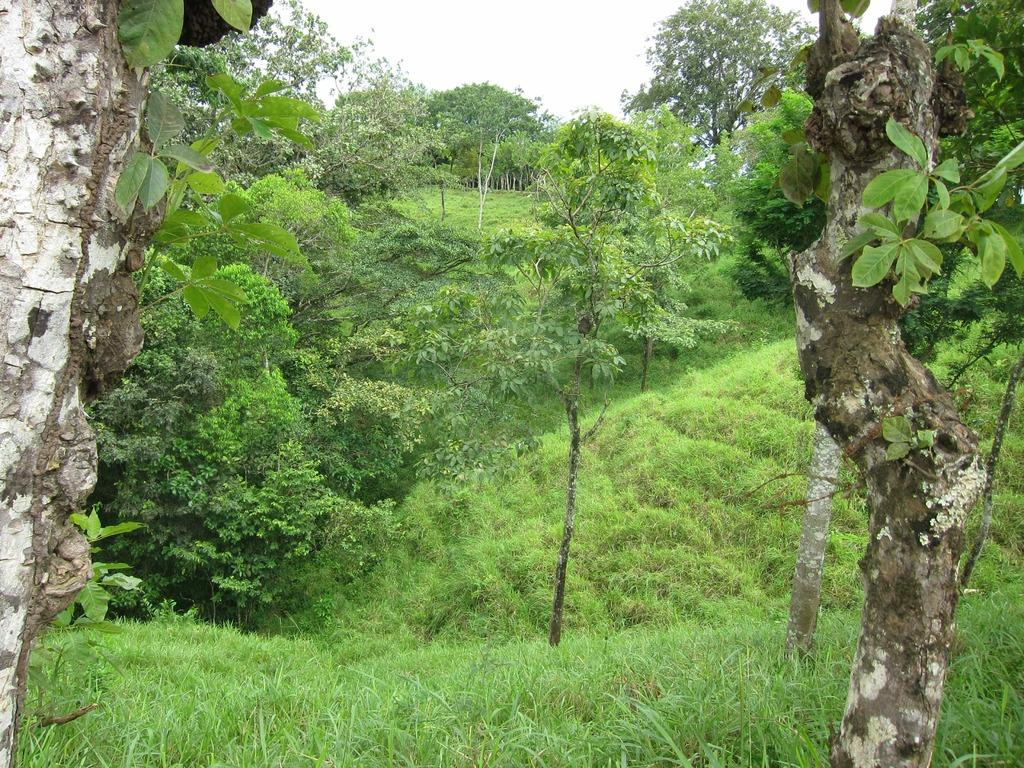What type of vegetation is on the ground in the image? There is grass on the ground in the image. What color is the grass? The grass is green in color. What other natural elements can be seen in the image? There are trees in the image. What colors are present on the trees? The trees have green, white, and brown colors. Where are the trees located in the image? There are trees visible in the background of the image. What is visible in the background of the image besides trees? The sky is visible in the background of the image. What is the price of the arm visible in the image? There is no arm present in the image, so it is not possible to determine its price. 